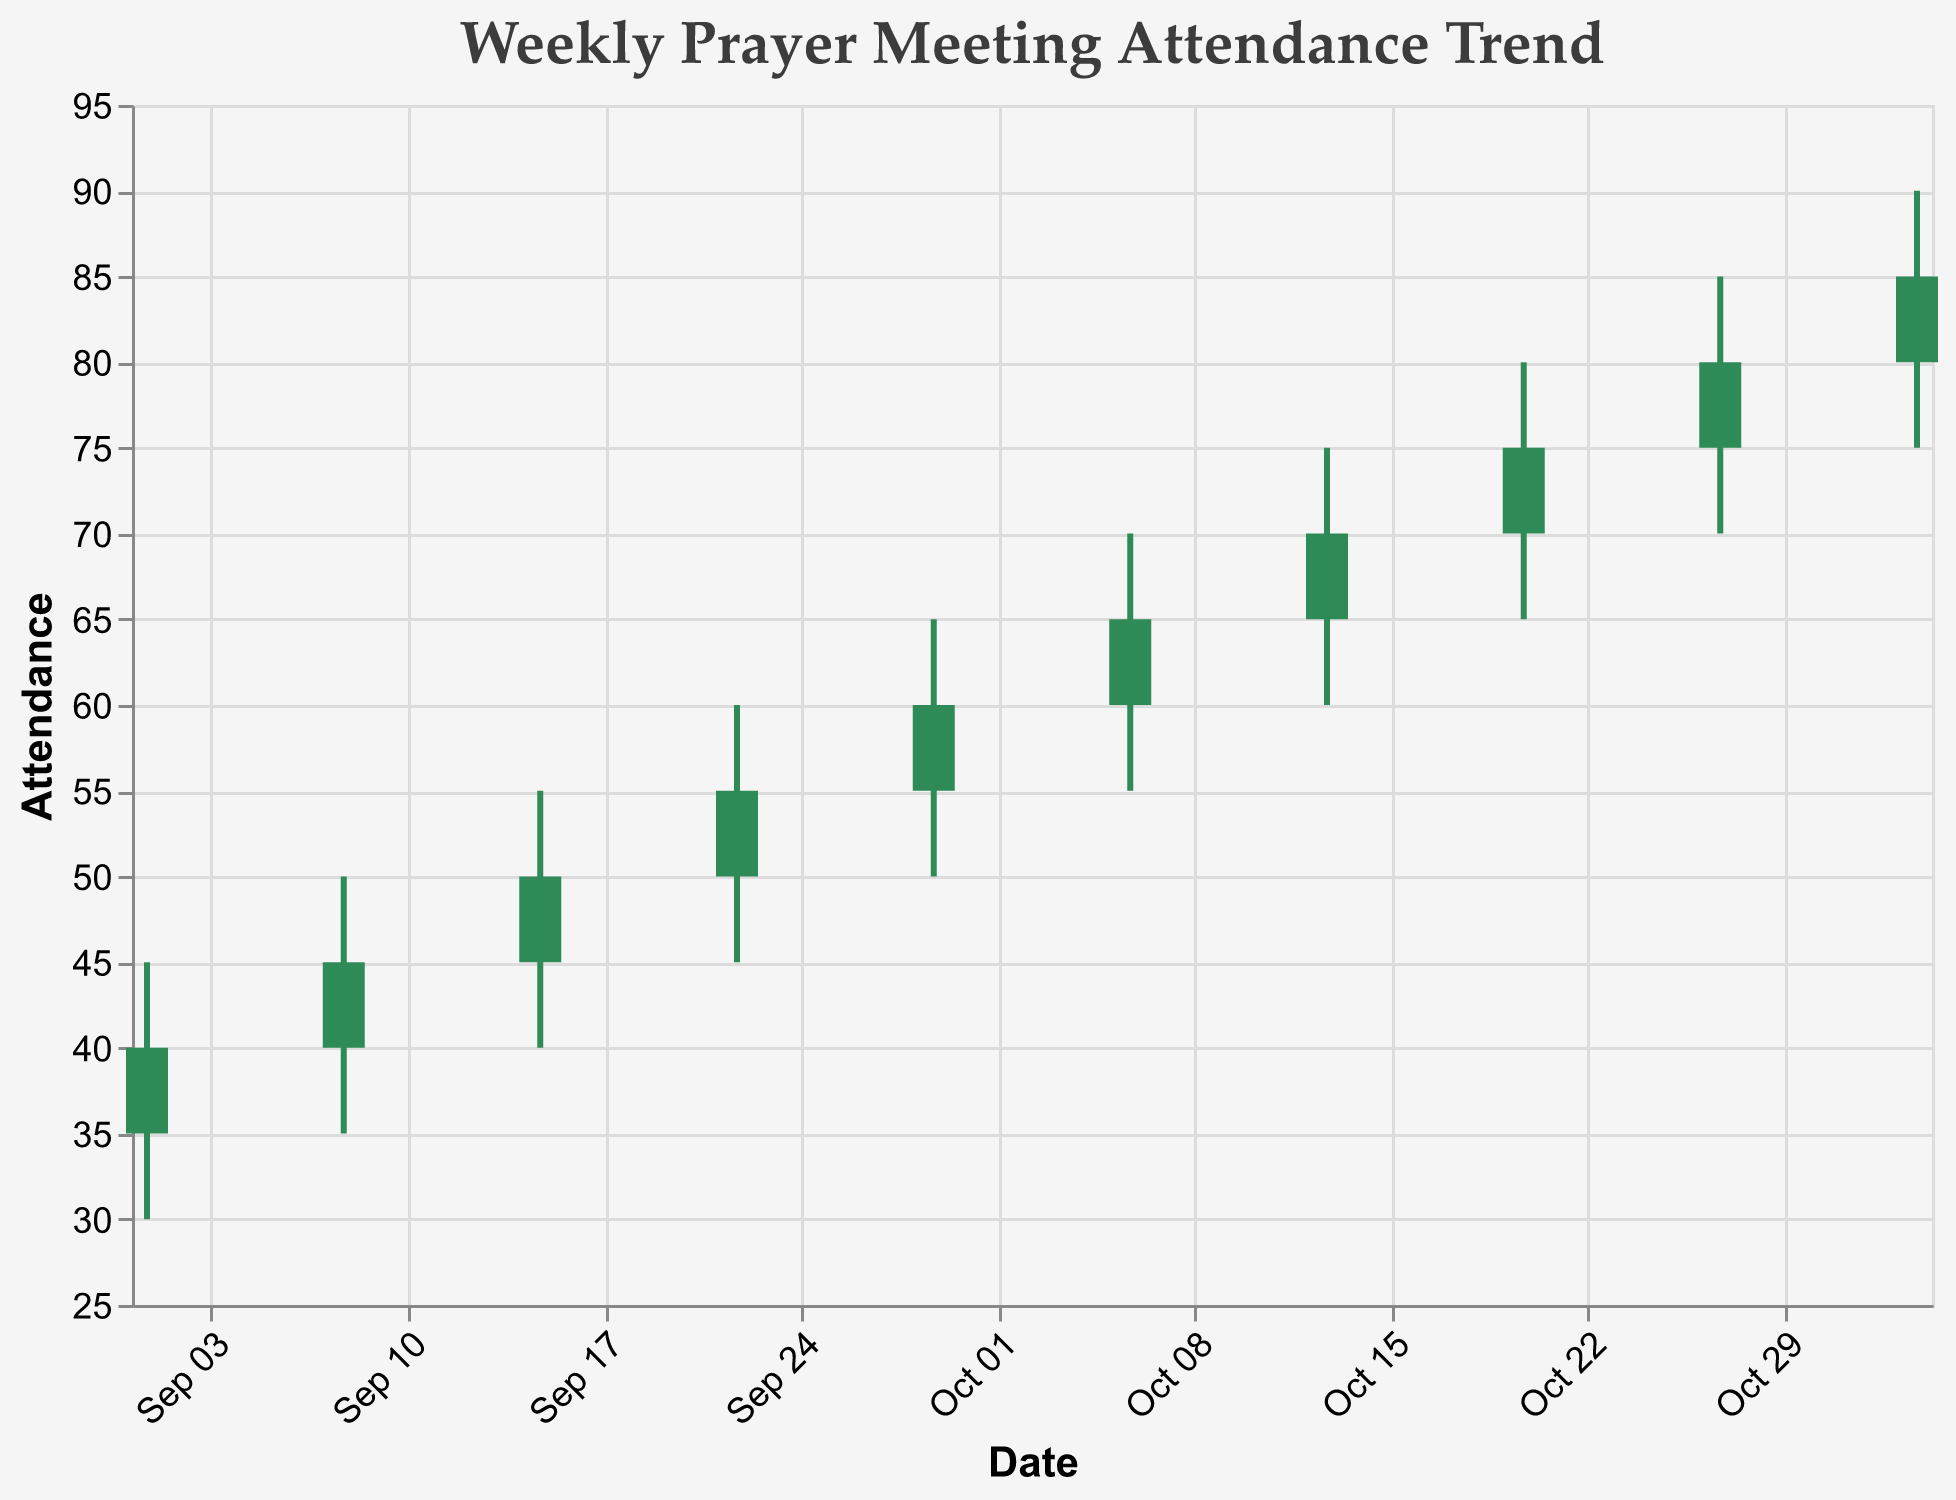How many weeks are represented in the plot? Count the number of data points in the figure, which represent weeks. There are 10 data points, each representing a week.
Answer: 10 What is the highest attendance recorded? Identify the highest value on the vertical axis for "Attendance." The highest recorded value is 90 on the week of 2023-11-03.
Answer: 90 For which week was the lowest opening attendance recorded? Look for the lowest "Open" value in the dataset. The lowest opening attendance was 35 on the week of 2023-09-01.
Answer: 2023-09-01 What is the average closing attendance for all weeks? Add up all the "Close" values and divide by the number of weeks: (40+45+50+55+60+65+70+75+80+85) / 10 = 62.5
Answer: 62.5 Which week had the largest range of attendance values and what was that range? Find the week with the greatest difference between the "High" and "Low" values. The largest range is 90 - 75 = 15 on the week of 2023-11-03.
Answer: 2023-11-03, 15 During which week did the closing attendance exceed the opening attendance by the largest amount? Calculate the difference between "Close" and "Open" for each week and find the maximum. The largest difference is 5 (70-65) for the week of 2023-10-13.
Answer: 2023-10-13 Compare the opening attendance on 2023-09-01 with the closing attendance on 2023-11-03. Which is higher? Compare the values: The opening attendance on 2023-09-01 is 35, and the closing attendance on 2023-11-03 is 85. 85 is higher than 35.
Answer: 2023-11-03 Did the attendance ever decrease from one week to the next? If so, state when. Check if the "Close" value of a week is less than the "Open" value of the following week. No such instance is observed in the given data.
Answer: No What was the attendance trend over the 10 weeks? The candlestick plot shows a steady increasing trend in both opening and closing attendance values over the 10-week period.
Answer: Increasing How much did the closing attendance increase from the first to the last week? Subtract the closing attendance value of the first week from that of the last week: 85 - 40 = 45.
Answer: 45 